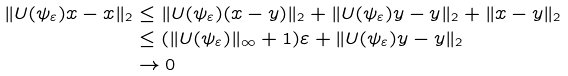Convert formula to latex. <formula><loc_0><loc_0><loc_500><loc_500>\| U ( \psi _ { \varepsilon } ) x - x \| _ { 2 } & \leq \| U ( \psi _ { \varepsilon } ) ( x - y ) \| _ { 2 } + \| U ( \psi _ { \varepsilon } ) y - y \| _ { 2 } + \| x - y \| _ { 2 } \\ & \leq ( \| U ( \psi _ { \varepsilon } ) \| _ { \infty } + 1 ) \varepsilon + \| U ( \psi _ { \varepsilon } ) y - y \| _ { 2 } \\ & \rightarrow 0</formula> 